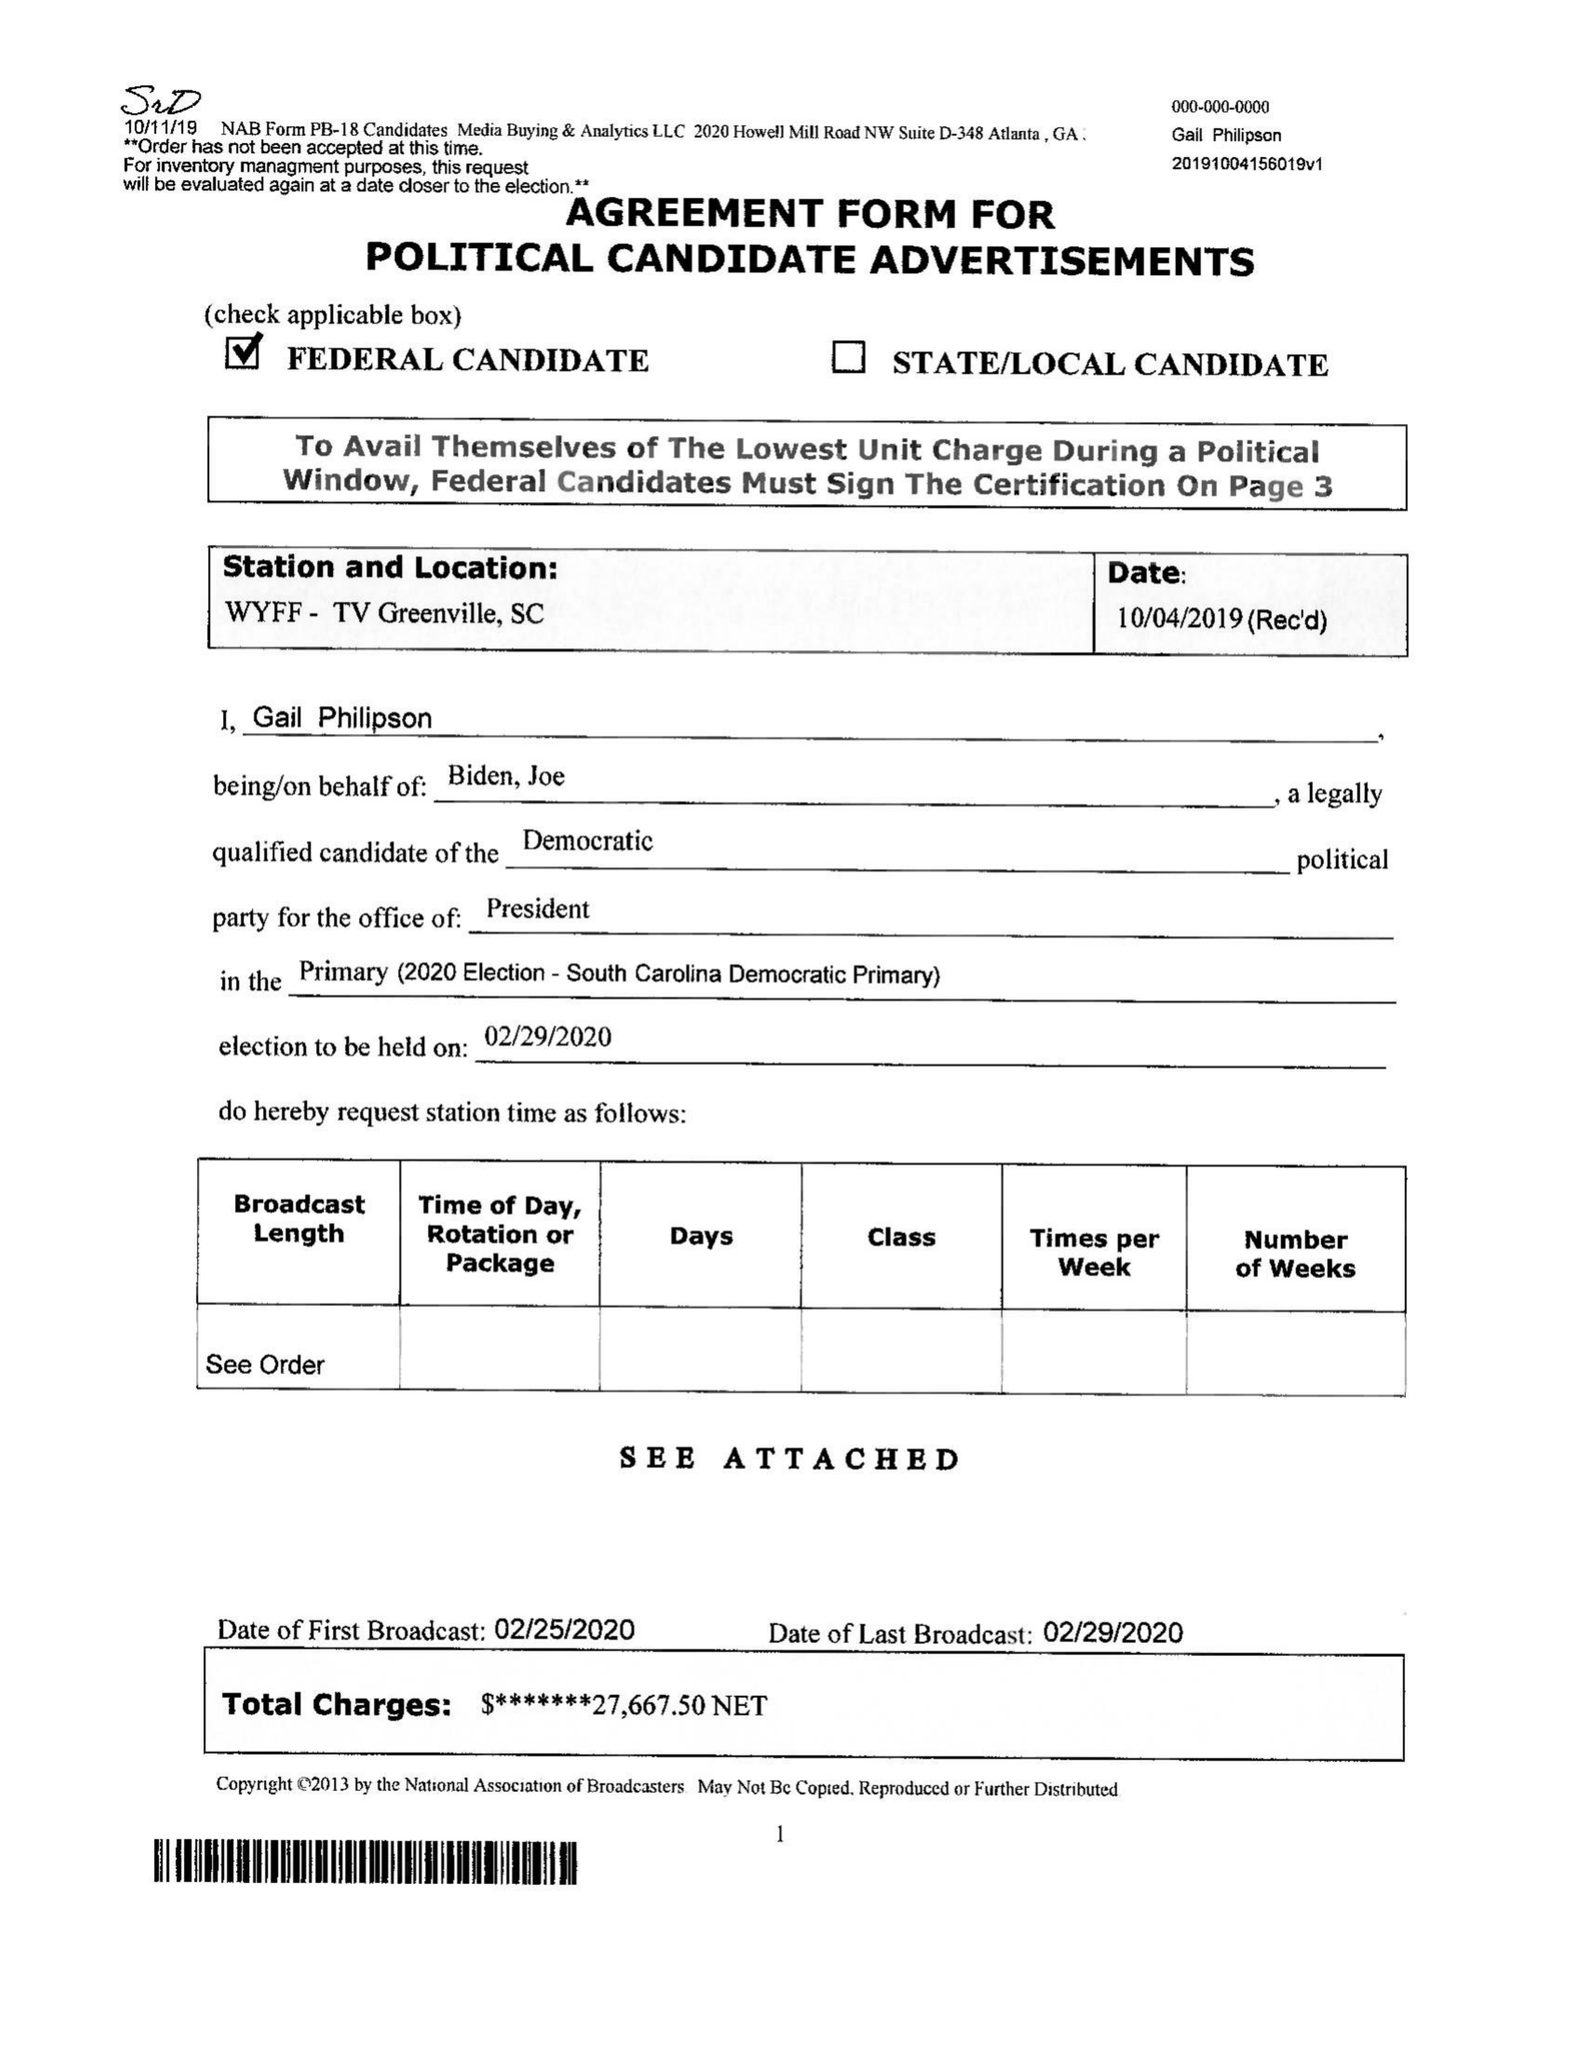What is the value for the flight_from?
Answer the question using a single word or phrase. 02/25/20 